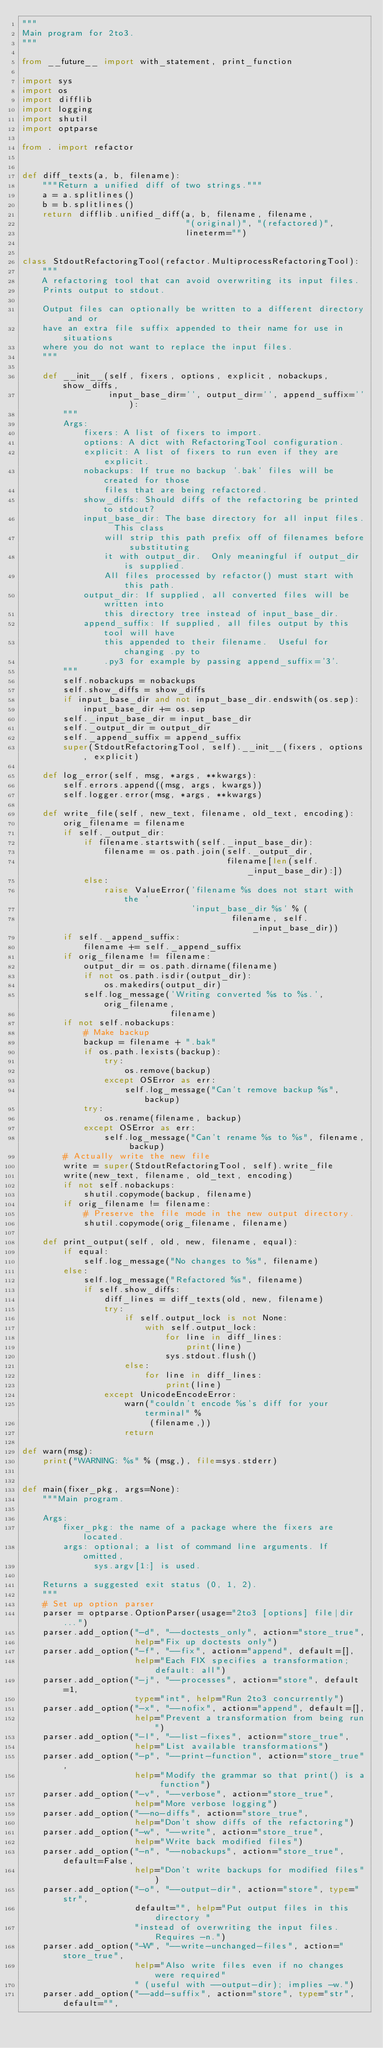Convert code to text. <code><loc_0><loc_0><loc_500><loc_500><_Python_>"""
Main program for 2to3.
"""

from __future__ import with_statement, print_function

import sys
import os
import difflib
import logging
import shutil
import optparse

from . import refactor


def diff_texts(a, b, filename):
    """Return a unified diff of two strings."""
    a = a.splitlines()
    b = b.splitlines()
    return difflib.unified_diff(a, b, filename, filename,
                                "(original)", "(refactored)",
                                lineterm="")


class StdoutRefactoringTool(refactor.MultiprocessRefactoringTool):
    """
    A refactoring tool that can avoid overwriting its input files.
    Prints output to stdout.

    Output files can optionally be written to a different directory and or
    have an extra file suffix appended to their name for use in situations
    where you do not want to replace the input files.
    """

    def __init__(self, fixers, options, explicit, nobackups, show_diffs,
                 input_base_dir='', output_dir='', append_suffix=''):
        """
        Args:
            fixers: A list of fixers to import.
            options: A dict with RefactoringTool configuration.
            explicit: A list of fixers to run even if they are explicit.
            nobackups: If true no backup '.bak' files will be created for those
                files that are being refactored.
            show_diffs: Should diffs of the refactoring be printed to stdout?
            input_base_dir: The base directory for all input files.  This class
                will strip this path prefix off of filenames before substituting
                it with output_dir.  Only meaningful if output_dir is supplied.
                All files processed by refactor() must start with this path.
            output_dir: If supplied, all converted files will be written into
                this directory tree instead of input_base_dir.
            append_suffix: If supplied, all files output by this tool will have
                this appended to their filename.  Useful for changing .py to
                .py3 for example by passing append_suffix='3'.
        """
        self.nobackups = nobackups
        self.show_diffs = show_diffs
        if input_base_dir and not input_base_dir.endswith(os.sep):
            input_base_dir += os.sep
        self._input_base_dir = input_base_dir
        self._output_dir = output_dir
        self._append_suffix = append_suffix
        super(StdoutRefactoringTool, self).__init__(fixers, options, explicit)

    def log_error(self, msg, *args, **kwargs):
        self.errors.append((msg, args, kwargs))
        self.logger.error(msg, *args, **kwargs)

    def write_file(self, new_text, filename, old_text, encoding):
        orig_filename = filename
        if self._output_dir:
            if filename.startswith(self._input_base_dir):
                filename = os.path.join(self._output_dir,
                                        filename[len(self._input_base_dir):])
            else:
                raise ValueError('filename %s does not start with the '
                                 'input_base_dir %s' % (
                                         filename, self._input_base_dir))
        if self._append_suffix:
            filename += self._append_suffix
        if orig_filename != filename:
            output_dir = os.path.dirname(filename)
            if not os.path.isdir(output_dir):
                os.makedirs(output_dir)
            self.log_message('Writing converted %s to %s.', orig_filename,
                             filename)
        if not self.nobackups:
            # Make backup
            backup = filename + ".bak"
            if os.path.lexists(backup):
                try:
                    os.remove(backup)
                except OSError as err:
                    self.log_message("Can't remove backup %s", backup)
            try:
                os.rename(filename, backup)
            except OSError as err:
                self.log_message("Can't rename %s to %s", filename, backup)
        # Actually write the new file
        write = super(StdoutRefactoringTool, self).write_file
        write(new_text, filename, old_text, encoding)
        if not self.nobackups:
            shutil.copymode(backup, filename)
        if orig_filename != filename:
            # Preserve the file mode in the new output directory.
            shutil.copymode(orig_filename, filename)

    def print_output(self, old, new, filename, equal):
        if equal:
            self.log_message("No changes to %s", filename)
        else:
            self.log_message("Refactored %s", filename)
            if self.show_diffs:
                diff_lines = diff_texts(old, new, filename)
                try:
                    if self.output_lock is not None:
                        with self.output_lock:
                            for line in diff_lines:
                                print(line)
                            sys.stdout.flush()
                    else:
                        for line in diff_lines:
                            print(line)
                except UnicodeEncodeError:
                    warn("couldn't encode %s's diff for your terminal" %
                         (filename,))
                    return

def warn(msg):
    print("WARNING: %s" % (msg,), file=sys.stderr)


def main(fixer_pkg, args=None):
    """Main program.

    Args:
        fixer_pkg: the name of a package where the fixers are located.
        args: optional; a list of command line arguments. If omitted,
              sys.argv[1:] is used.

    Returns a suggested exit status (0, 1, 2).
    """
    # Set up option parser
    parser = optparse.OptionParser(usage="2to3 [options] file|dir ...")
    parser.add_option("-d", "--doctests_only", action="store_true",
                      help="Fix up doctests only")
    parser.add_option("-f", "--fix", action="append", default=[],
                      help="Each FIX specifies a transformation; default: all")
    parser.add_option("-j", "--processes", action="store", default=1,
                      type="int", help="Run 2to3 concurrently")
    parser.add_option("-x", "--nofix", action="append", default=[],
                      help="Prevent a transformation from being run")
    parser.add_option("-l", "--list-fixes", action="store_true",
                      help="List available transformations")
    parser.add_option("-p", "--print-function", action="store_true",
                      help="Modify the grammar so that print() is a function")
    parser.add_option("-v", "--verbose", action="store_true",
                      help="More verbose logging")
    parser.add_option("--no-diffs", action="store_true",
                      help="Don't show diffs of the refactoring")
    parser.add_option("-w", "--write", action="store_true",
                      help="Write back modified files")
    parser.add_option("-n", "--nobackups", action="store_true", default=False,
                      help="Don't write backups for modified files")
    parser.add_option("-o", "--output-dir", action="store", type="str",
                      default="", help="Put output files in this directory "
                      "instead of overwriting the input files.  Requires -n.")
    parser.add_option("-W", "--write-unchanged-files", action="store_true",
                      help="Also write files even if no changes were required"
                      " (useful with --output-dir); implies -w.")
    parser.add_option("--add-suffix", action="store", type="str", default="",</code> 